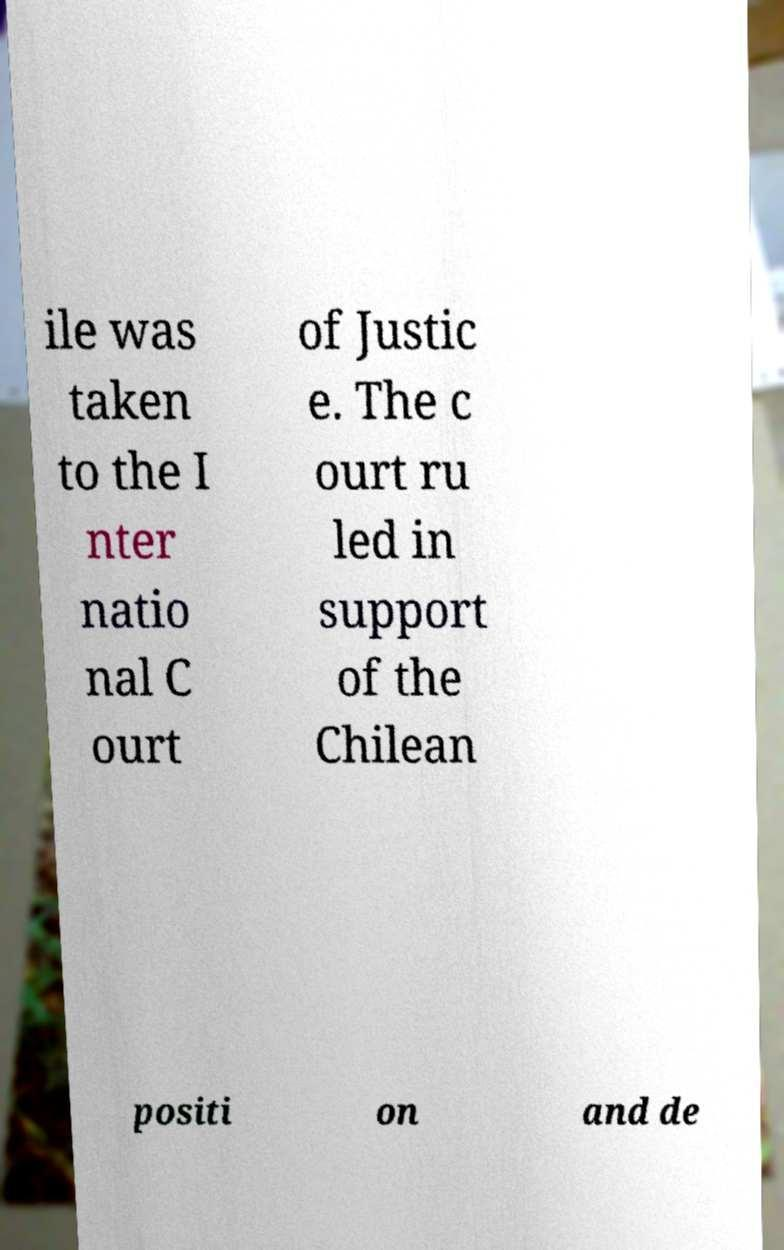Can you read and provide the text displayed in the image?This photo seems to have some interesting text. Can you extract and type it out for me? ile was taken to the I nter natio nal C ourt of Justic e. The c ourt ru led in support of the Chilean positi on and de 